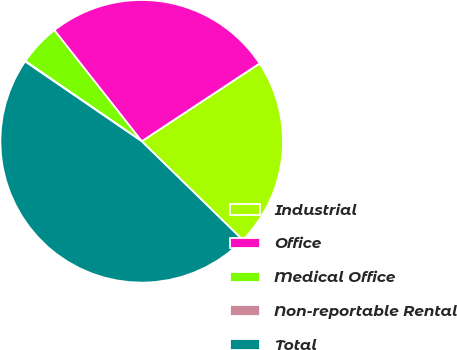<chart> <loc_0><loc_0><loc_500><loc_500><pie_chart><fcel>Industrial<fcel>Office<fcel>Medical Office<fcel>Non-reportable Rental<fcel>Total<nl><fcel>21.6%<fcel>26.32%<fcel>4.78%<fcel>0.06%<fcel>47.24%<nl></chart> 